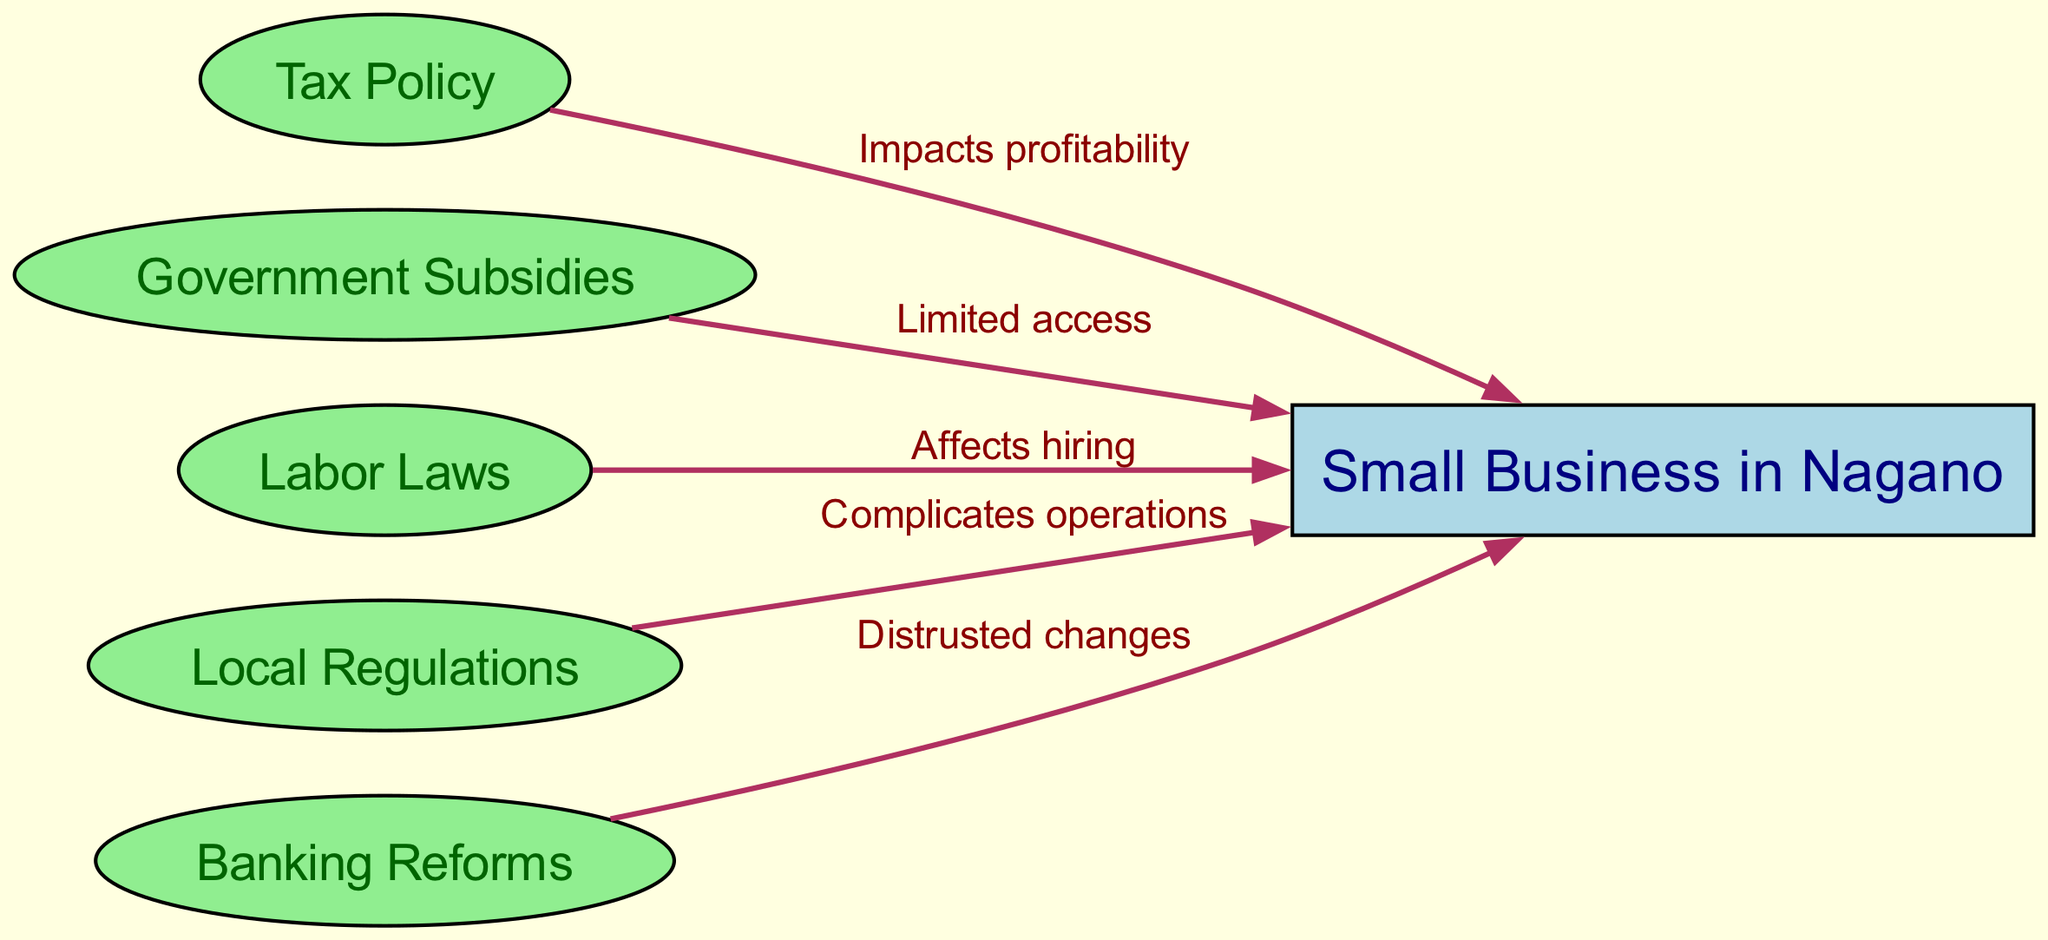What is the main subject of the diagram? The main subject of the diagram is located in the center, specifically represented by the node labeled "Small Business in Nagano".
Answer: Small Business in Nagano How many nodes are there in total? Counting all the nodes listed, including the central subject and other policies, there are six nodes in total.
Answer: 6 What does the edge from "taxPolicy" to "smallBusiness" signify? The edge represents a relationship indicating that "Tax Policy" impacts the profitability of "Small Business in Nagano".
Answer: Impacts profitability Which government policy affects hiring? The node that signifies the policy influencing hiring is "Labor Laws", which is connected to "Small Business in Nagano".
Answer: Labor Laws What is a concern associated with "bankingReforms"? The edge connecting "bankingReforms" to "smallBusiness" indicates that the concern is distrust, as expressed in the label "Distrusted changes".
Answer: Distrusted changes How do "subsidies" relate to small businesses? The relationship shows that "Government Subsidies" have limited access for "Small Business in Nagano", as indicated by the label on the connecting edge.
Answer: Limited access Which policy complicates operations for small businesses? The node labeled "Local Regulations" directly relates to "Small Business in Nagano", and the edge indicates that it complicates their operations.
Answer: Complicates operations Which influencing factor is directly related to profitability? The edge from "taxPolicy" indicates that it has a direct relationship with the profitability of "Small Business in Nagano".
Answer: Tax Policy 